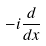Convert formula to latex. <formula><loc_0><loc_0><loc_500><loc_500>- i \frac { d } { d x }</formula> 